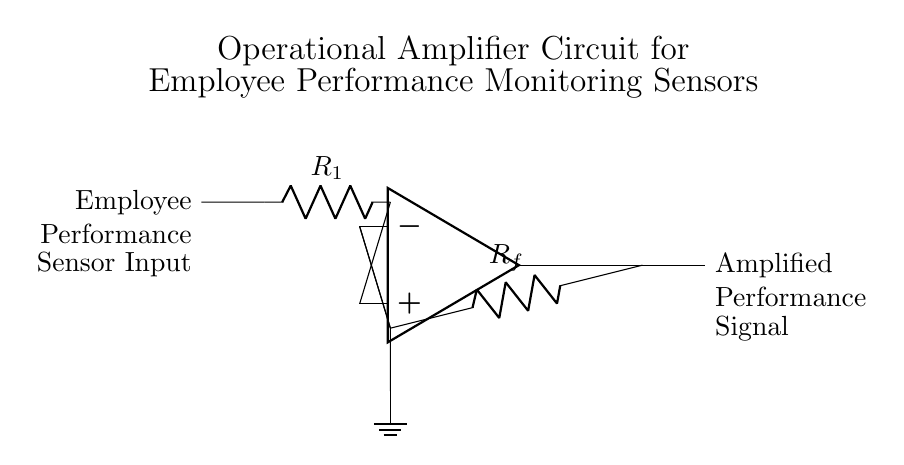What type of amplifier is represented in this circuit? The circuit is an operational amplifier, as indicated by the op-amp symbol at the center of the diagram.
Answer: operational amplifier What do R1 and Rf represent in this circuit? R1 is the input resistor, and Rf is the feedback resistor. Their roles involve determining the gain of the amplifier.
Answer: input and feedback resistors What is the purpose of the voltage applied at the input? The voltage applied at the input is used to measure employee performance through the sensor, which is then amplified.
Answer: measure employee performance Explain the relationship between input and output signals in this circuit. The output signal is a scaled version of the input signal, determined by the ratio of Rf to R1, indicating how much the input performance signal is amplified.
Answer: output is scaled input Where is the ground reference in this circuit? The ground reference is located at the bottom of Rf, which acts as a common reference point for the circuit.
Answer: at the bottom of Rf What happens if Rf is increased while keeping R1 constant? Increasing Rf while keeping R1 constant will increase the gain of the amplifier, resulting in a larger output signal for the same input.
Answer: gain increases Is there any feedback in this operational amplifier circuit? Yes, there is feedback in this circuit as indicated by the connection from the output back to the inverting terminal through Rf.
Answer: Yes, feedback exists 